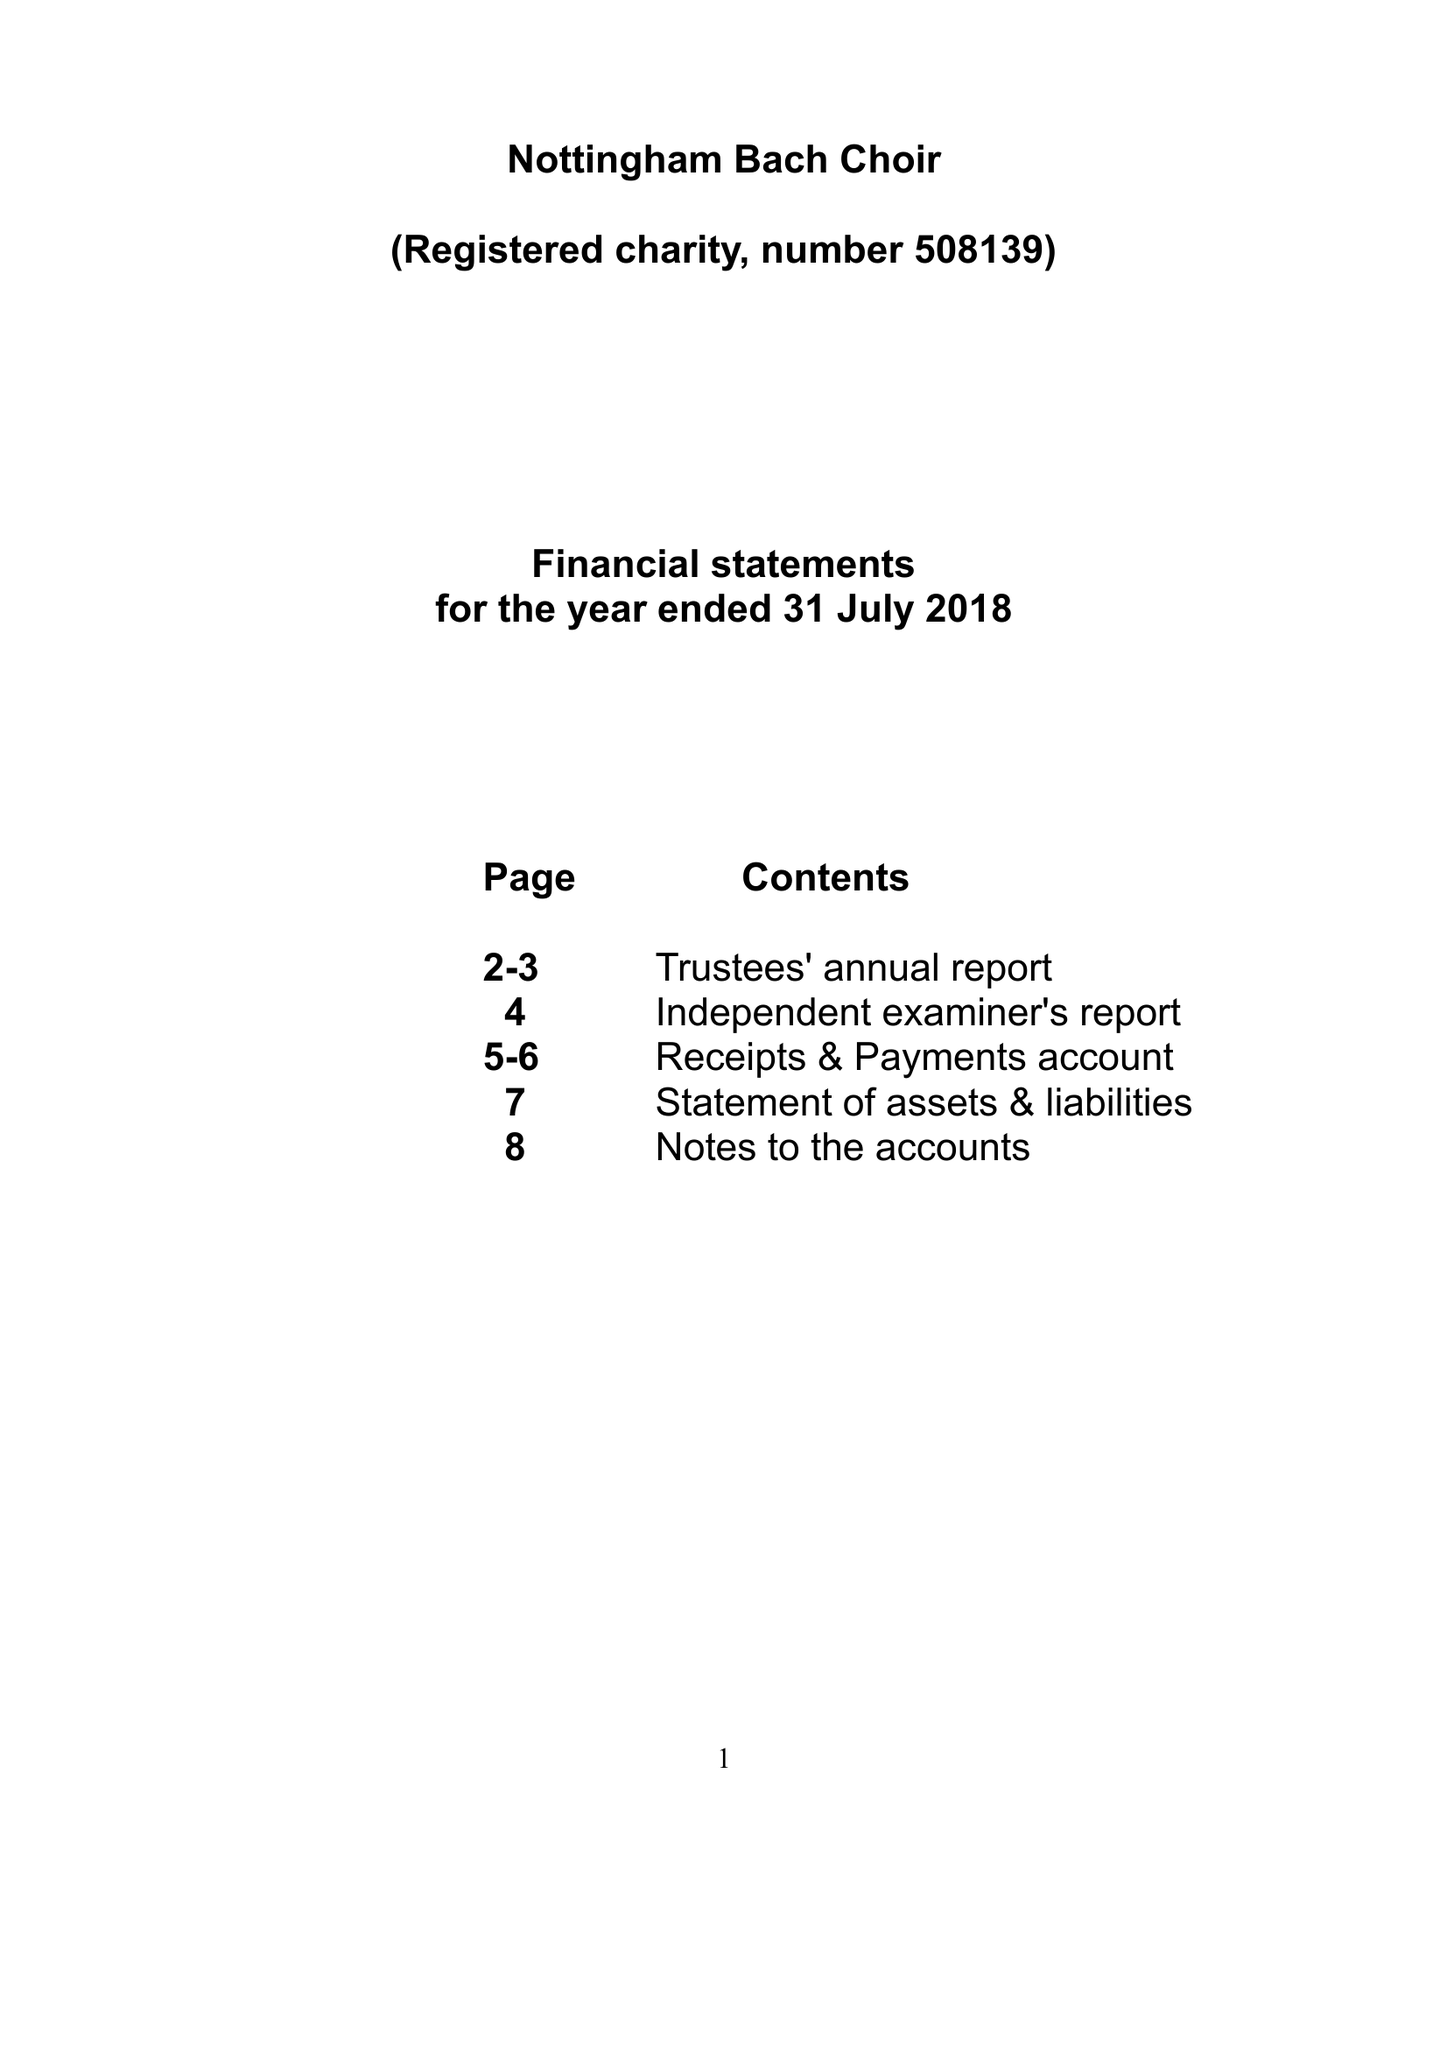What is the value for the charity_name?
Answer the question using a single word or phrase. Nottingham Bach Choir 